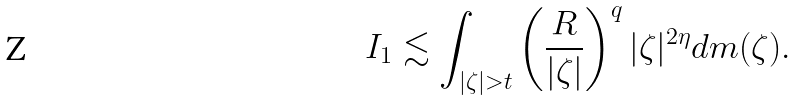Convert formula to latex. <formula><loc_0><loc_0><loc_500><loc_500>I _ { 1 } \lesssim \int _ { | \zeta | > t } \left ( \frac { R } { | \zeta | } \right ) ^ { q } | \zeta | ^ { 2 \eta } d m ( \zeta ) .</formula> 